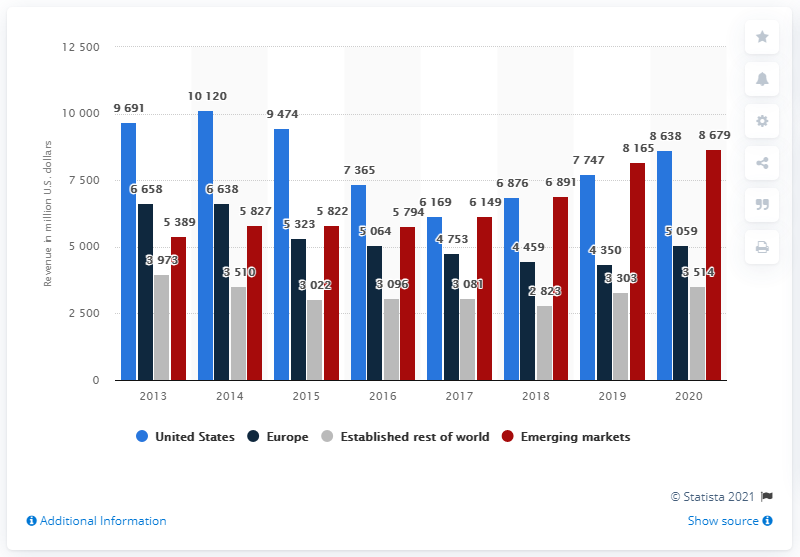Point out several critical features in this image. In 2020, AstraZeneca's revenue in the U.S. amounted to $8,638. 